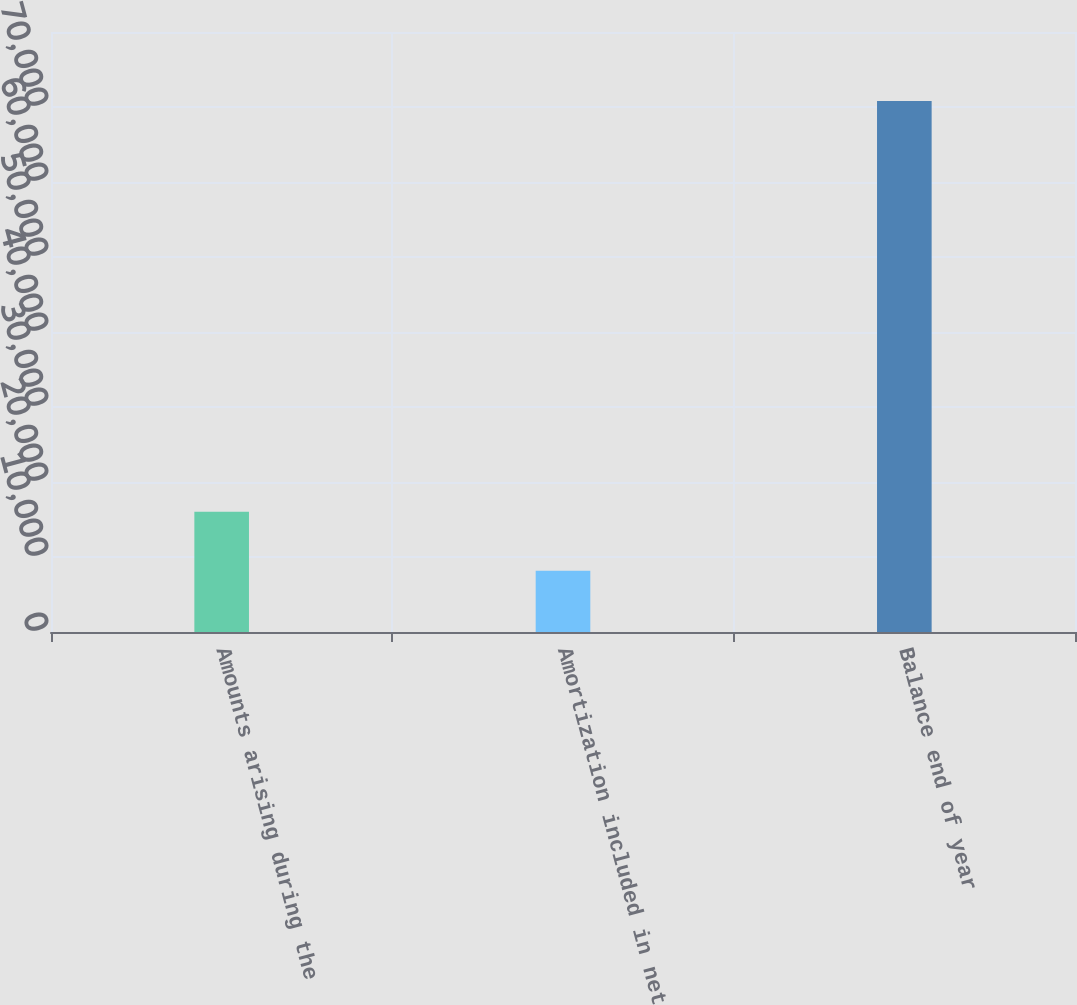<chart> <loc_0><loc_0><loc_500><loc_500><bar_chart><fcel>Amounts arising during the<fcel>Amortization included in net<fcel>Balance end of year<nl><fcel>16031<fcel>8159<fcel>70803<nl></chart> 